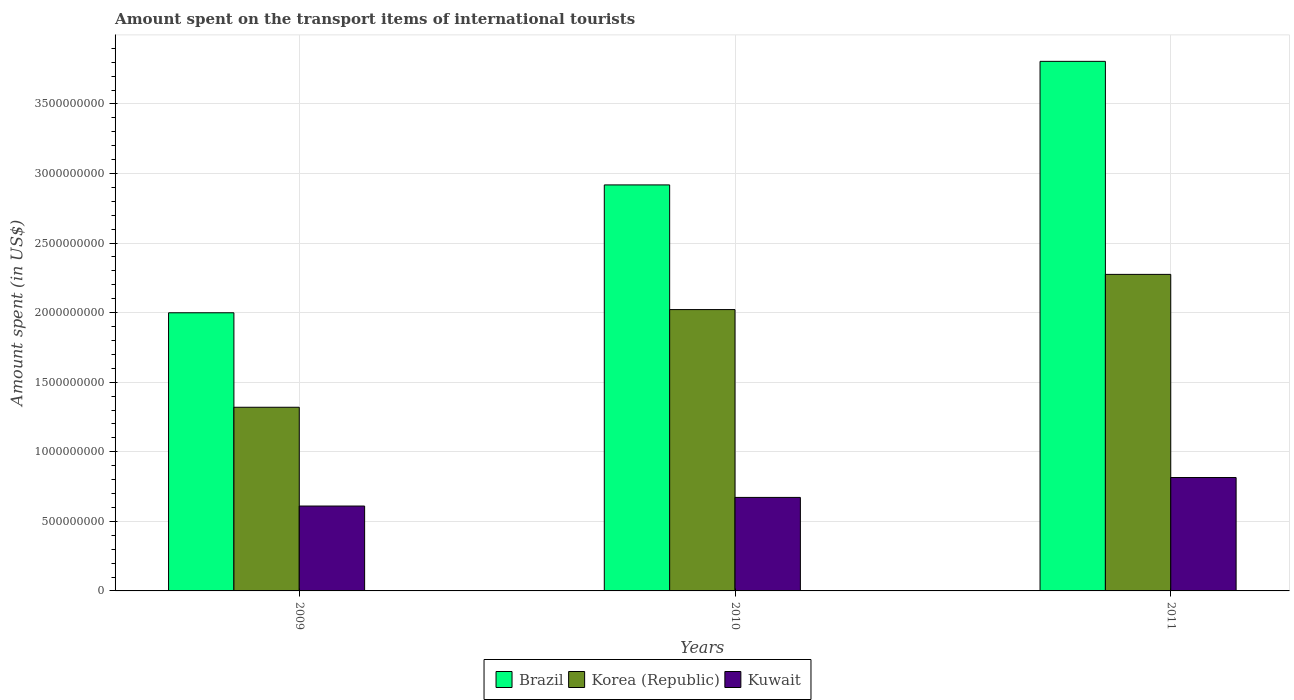How many different coloured bars are there?
Provide a succinct answer. 3. How many groups of bars are there?
Keep it short and to the point. 3. Are the number of bars per tick equal to the number of legend labels?
Your answer should be compact. Yes. What is the amount spent on the transport items of international tourists in Korea (Republic) in 2010?
Your answer should be compact. 2.02e+09. Across all years, what is the maximum amount spent on the transport items of international tourists in Brazil?
Keep it short and to the point. 3.81e+09. Across all years, what is the minimum amount spent on the transport items of international tourists in Brazil?
Ensure brevity in your answer.  2.00e+09. What is the total amount spent on the transport items of international tourists in Kuwait in the graph?
Your answer should be very brief. 2.10e+09. What is the difference between the amount spent on the transport items of international tourists in Korea (Republic) in 2009 and that in 2010?
Give a very brief answer. -7.02e+08. What is the difference between the amount spent on the transport items of international tourists in Kuwait in 2010 and the amount spent on the transport items of international tourists in Korea (Republic) in 2009?
Your answer should be compact. -6.48e+08. What is the average amount spent on the transport items of international tourists in Korea (Republic) per year?
Your answer should be compact. 1.87e+09. In the year 2010, what is the difference between the amount spent on the transport items of international tourists in Korea (Republic) and amount spent on the transport items of international tourists in Kuwait?
Your answer should be very brief. 1.35e+09. What is the ratio of the amount spent on the transport items of international tourists in Korea (Republic) in 2009 to that in 2010?
Ensure brevity in your answer.  0.65. Is the amount spent on the transport items of international tourists in Korea (Republic) in 2010 less than that in 2011?
Ensure brevity in your answer.  Yes. Is the difference between the amount spent on the transport items of international tourists in Korea (Republic) in 2009 and 2011 greater than the difference between the amount spent on the transport items of international tourists in Kuwait in 2009 and 2011?
Ensure brevity in your answer.  No. What is the difference between the highest and the second highest amount spent on the transport items of international tourists in Korea (Republic)?
Ensure brevity in your answer.  2.53e+08. What is the difference between the highest and the lowest amount spent on the transport items of international tourists in Brazil?
Provide a short and direct response. 1.81e+09. What does the 2nd bar from the left in 2011 represents?
Offer a terse response. Korea (Republic). Are all the bars in the graph horizontal?
Offer a terse response. No. Are the values on the major ticks of Y-axis written in scientific E-notation?
Your answer should be compact. No. Does the graph contain grids?
Provide a short and direct response. Yes. What is the title of the graph?
Offer a very short reply. Amount spent on the transport items of international tourists. What is the label or title of the Y-axis?
Provide a short and direct response. Amount spent (in US$). What is the Amount spent (in US$) of Brazil in 2009?
Provide a succinct answer. 2.00e+09. What is the Amount spent (in US$) of Korea (Republic) in 2009?
Offer a very short reply. 1.32e+09. What is the Amount spent (in US$) of Kuwait in 2009?
Your response must be concise. 6.10e+08. What is the Amount spent (in US$) in Brazil in 2010?
Offer a very short reply. 2.92e+09. What is the Amount spent (in US$) of Korea (Republic) in 2010?
Keep it short and to the point. 2.02e+09. What is the Amount spent (in US$) in Kuwait in 2010?
Make the answer very short. 6.72e+08. What is the Amount spent (in US$) in Brazil in 2011?
Keep it short and to the point. 3.81e+09. What is the Amount spent (in US$) in Korea (Republic) in 2011?
Your answer should be compact. 2.28e+09. What is the Amount spent (in US$) of Kuwait in 2011?
Offer a very short reply. 8.15e+08. Across all years, what is the maximum Amount spent (in US$) in Brazil?
Provide a short and direct response. 3.81e+09. Across all years, what is the maximum Amount spent (in US$) in Korea (Republic)?
Your response must be concise. 2.28e+09. Across all years, what is the maximum Amount spent (in US$) in Kuwait?
Your response must be concise. 8.15e+08. Across all years, what is the minimum Amount spent (in US$) in Brazil?
Provide a succinct answer. 2.00e+09. Across all years, what is the minimum Amount spent (in US$) in Korea (Republic)?
Provide a short and direct response. 1.32e+09. Across all years, what is the minimum Amount spent (in US$) in Kuwait?
Make the answer very short. 6.10e+08. What is the total Amount spent (in US$) of Brazil in the graph?
Give a very brief answer. 8.72e+09. What is the total Amount spent (in US$) in Korea (Republic) in the graph?
Offer a very short reply. 5.62e+09. What is the total Amount spent (in US$) in Kuwait in the graph?
Your response must be concise. 2.10e+09. What is the difference between the Amount spent (in US$) in Brazil in 2009 and that in 2010?
Keep it short and to the point. -9.19e+08. What is the difference between the Amount spent (in US$) in Korea (Republic) in 2009 and that in 2010?
Keep it short and to the point. -7.02e+08. What is the difference between the Amount spent (in US$) in Kuwait in 2009 and that in 2010?
Your answer should be very brief. -6.20e+07. What is the difference between the Amount spent (in US$) in Brazil in 2009 and that in 2011?
Provide a succinct answer. -1.81e+09. What is the difference between the Amount spent (in US$) of Korea (Republic) in 2009 and that in 2011?
Provide a short and direct response. -9.55e+08. What is the difference between the Amount spent (in US$) of Kuwait in 2009 and that in 2011?
Your response must be concise. -2.05e+08. What is the difference between the Amount spent (in US$) of Brazil in 2010 and that in 2011?
Offer a very short reply. -8.88e+08. What is the difference between the Amount spent (in US$) in Korea (Republic) in 2010 and that in 2011?
Keep it short and to the point. -2.53e+08. What is the difference between the Amount spent (in US$) of Kuwait in 2010 and that in 2011?
Offer a very short reply. -1.43e+08. What is the difference between the Amount spent (in US$) of Brazil in 2009 and the Amount spent (in US$) of Korea (Republic) in 2010?
Provide a succinct answer. -2.30e+07. What is the difference between the Amount spent (in US$) in Brazil in 2009 and the Amount spent (in US$) in Kuwait in 2010?
Your answer should be very brief. 1.33e+09. What is the difference between the Amount spent (in US$) of Korea (Republic) in 2009 and the Amount spent (in US$) of Kuwait in 2010?
Your answer should be very brief. 6.48e+08. What is the difference between the Amount spent (in US$) of Brazil in 2009 and the Amount spent (in US$) of Korea (Republic) in 2011?
Provide a succinct answer. -2.76e+08. What is the difference between the Amount spent (in US$) in Brazil in 2009 and the Amount spent (in US$) in Kuwait in 2011?
Keep it short and to the point. 1.18e+09. What is the difference between the Amount spent (in US$) in Korea (Republic) in 2009 and the Amount spent (in US$) in Kuwait in 2011?
Ensure brevity in your answer.  5.05e+08. What is the difference between the Amount spent (in US$) of Brazil in 2010 and the Amount spent (in US$) of Korea (Republic) in 2011?
Ensure brevity in your answer.  6.43e+08. What is the difference between the Amount spent (in US$) in Brazil in 2010 and the Amount spent (in US$) in Kuwait in 2011?
Your response must be concise. 2.10e+09. What is the difference between the Amount spent (in US$) of Korea (Republic) in 2010 and the Amount spent (in US$) of Kuwait in 2011?
Make the answer very short. 1.21e+09. What is the average Amount spent (in US$) of Brazil per year?
Your response must be concise. 2.91e+09. What is the average Amount spent (in US$) of Korea (Republic) per year?
Provide a succinct answer. 1.87e+09. What is the average Amount spent (in US$) of Kuwait per year?
Your answer should be compact. 6.99e+08. In the year 2009, what is the difference between the Amount spent (in US$) of Brazil and Amount spent (in US$) of Korea (Republic)?
Your response must be concise. 6.79e+08. In the year 2009, what is the difference between the Amount spent (in US$) in Brazil and Amount spent (in US$) in Kuwait?
Provide a short and direct response. 1.39e+09. In the year 2009, what is the difference between the Amount spent (in US$) of Korea (Republic) and Amount spent (in US$) of Kuwait?
Ensure brevity in your answer.  7.10e+08. In the year 2010, what is the difference between the Amount spent (in US$) of Brazil and Amount spent (in US$) of Korea (Republic)?
Your response must be concise. 8.96e+08. In the year 2010, what is the difference between the Amount spent (in US$) in Brazil and Amount spent (in US$) in Kuwait?
Your response must be concise. 2.25e+09. In the year 2010, what is the difference between the Amount spent (in US$) of Korea (Republic) and Amount spent (in US$) of Kuwait?
Provide a short and direct response. 1.35e+09. In the year 2011, what is the difference between the Amount spent (in US$) in Brazil and Amount spent (in US$) in Korea (Republic)?
Make the answer very short. 1.53e+09. In the year 2011, what is the difference between the Amount spent (in US$) in Brazil and Amount spent (in US$) in Kuwait?
Give a very brief answer. 2.99e+09. In the year 2011, what is the difference between the Amount spent (in US$) of Korea (Republic) and Amount spent (in US$) of Kuwait?
Ensure brevity in your answer.  1.46e+09. What is the ratio of the Amount spent (in US$) of Brazil in 2009 to that in 2010?
Your answer should be very brief. 0.69. What is the ratio of the Amount spent (in US$) in Korea (Republic) in 2009 to that in 2010?
Provide a succinct answer. 0.65. What is the ratio of the Amount spent (in US$) in Kuwait in 2009 to that in 2010?
Offer a terse response. 0.91. What is the ratio of the Amount spent (in US$) of Brazil in 2009 to that in 2011?
Keep it short and to the point. 0.53. What is the ratio of the Amount spent (in US$) of Korea (Republic) in 2009 to that in 2011?
Your answer should be compact. 0.58. What is the ratio of the Amount spent (in US$) of Kuwait in 2009 to that in 2011?
Ensure brevity in your answer.  0.75. What is the ratio of the Amount spent (in US$) in Brazil in 2010 to that in 2011?
Provide a succinct answer. 0.77. What is the ratio of the Amount spent (in US$) of Korea (Republic) in 2010 to that in 2011?
Give a very brief answer. 0.89. What is the ratio of the Amount spent (in US$) of Kuwait in 2010 to that in 2011?
Your answer should be compact. 0.82. What is the difference between the highest and the second highest Amount spent (in US$) in Brazil?
Give a very brief answer. 8.88e+08. What is the difference between the highest and the second highest Amount spent (in US$) in Korea (Republic)?
Provide a short and direct response. 2.53e+08. What is the difference between the highest and the second highest Amount spent (in US$) in Kuwait?
Your answer should be very brief. 1.43e+08. What is the difference between the highest and the lowest Amount spent (in US$) of Brazil?
Your answer should be very brief. 1.81e+09. What is the difference between the highest and the lowest Amount spent (in US$) in Korea (Republic)?
Make the answer very short. 9.55e+08. What is the difference between the highest and the lowest Amount spent (in US$) of Kuwait?
Ensure brevity in your answer.  2.05e+08. 